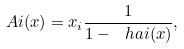<formula> <loc_0><loc_0><loc_500><loc_500>\ A i ( { x } ) = x _ { i } \frac { 1 } { 1 - \ h a i ( { x } ) } ,</formula> 